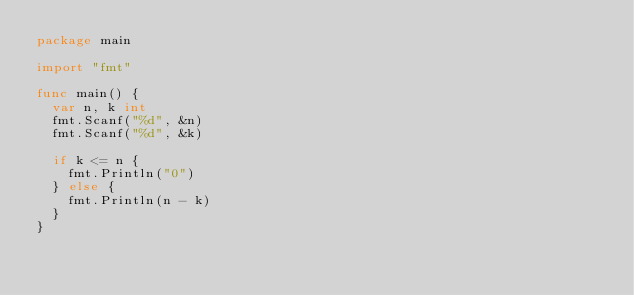<code> <loc_0><loc_0><loc_500><loc_500><_Go_>package main

import "fmt"

func main() {
	var n, k int
	fmt.Scanf("%d", &n)
	fmt.Scanf("%d", &k)

	if k <= n {
		fmt.Println("0")
	} else {
		fmt.Println(n - k)
	}
}
</code> 